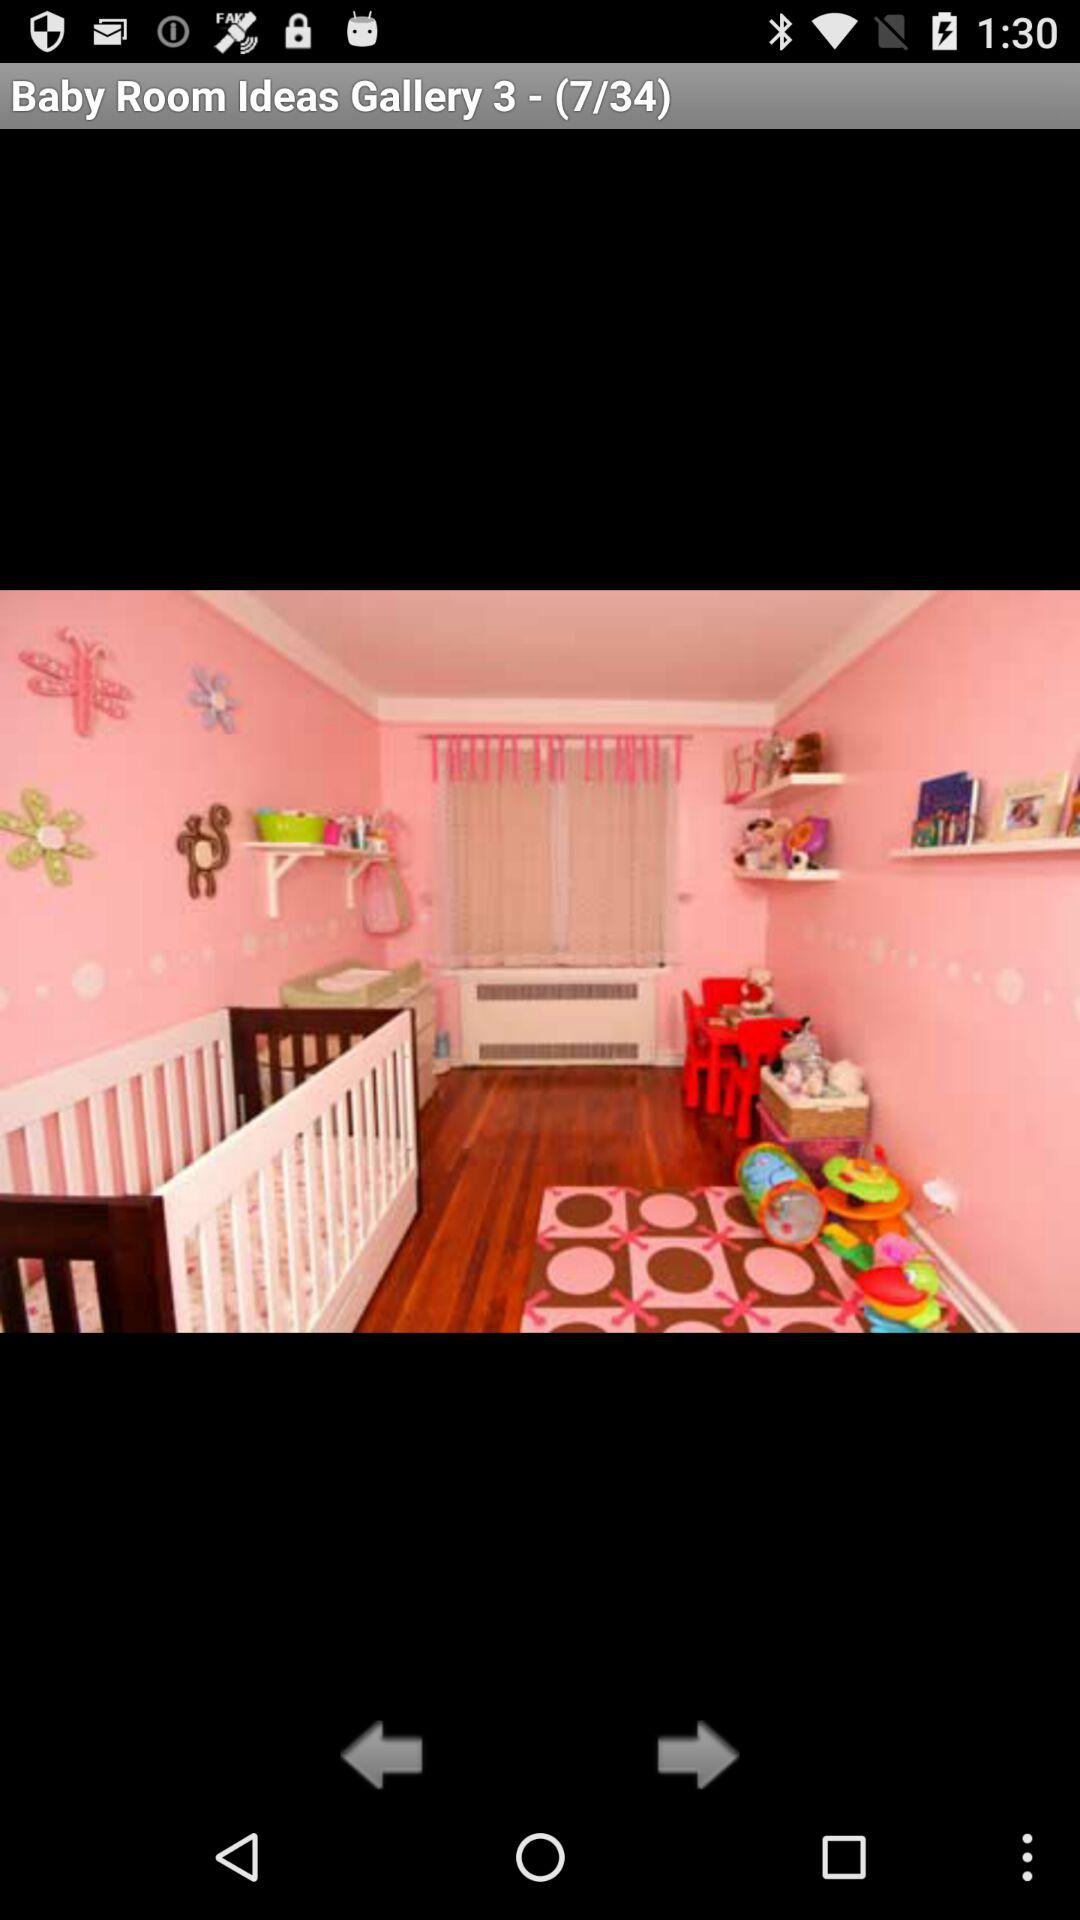What is the total number of images? The total number of images is 34. 